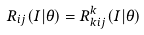Convert formula to latex. <formula><loc_0><loc_0><loc_500><loc_500>R _ { i j } ( I | \theta ) = R _ { k i j } ^ { k } ( I | \theta )</formula> 